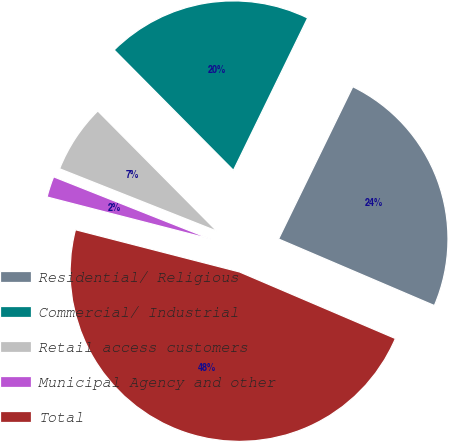Convert chart to OTSL. <chart><loc_0><loc_0><loc_500><loc_500><pie_chart><fcel>Residential/ Religious<fcel>Commercial/ Industrial<fcel>Retail access customers<fcel>Municipal Agency and other<fcel>Total<nl><fcel>24.21%<fcel>19.65%<fcel>6.56%<fcel>2.0%<fcel>47.59%<nl></chart> 